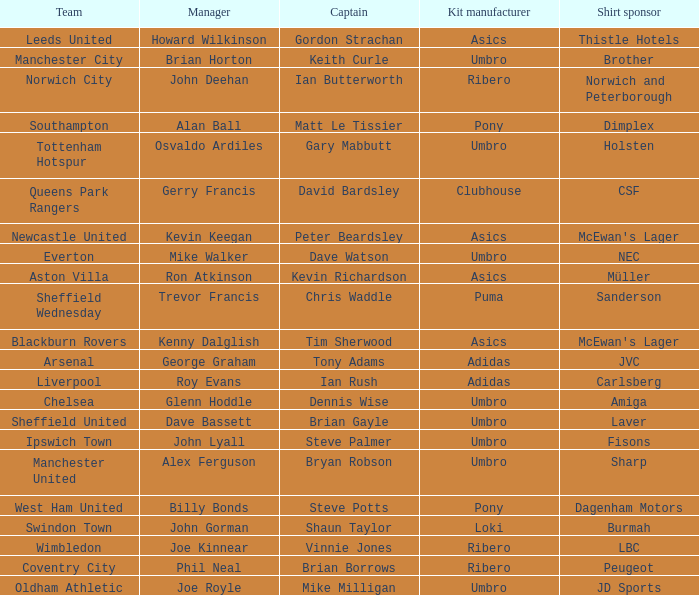Which captain has howard wilkinson as the manager? Gordon Strachan. 